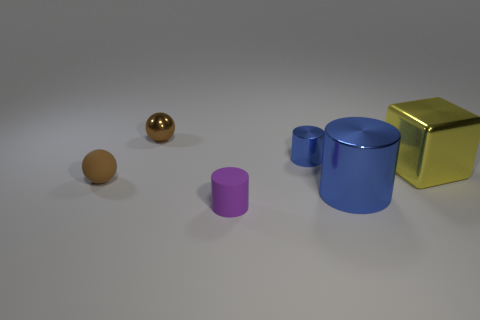Subtract all big cylinders. How many cylinders are left? 2 Subtract all purple balls. How many blue cylinders are left? 2 Subtract 1 cylinders. How many cylinders are left? 2 Add 4 tiny balls. How many objects exist? 10 Subtract all spheres. How many objects are left? 4 Subtract all red cylinders. Subtract all purple spheres. How many cylinders are left? 3 Subtract 0 green cubes. How many objects are left? 6 Subtract all blue metal objects. Subtract all yellow things. How many objects are left? 3 Add 3 tiny metal spheres. How many tiny metal spheres are left? 4 Add 2 large blue shiny cubes. How many large blue shiny cubes exist? 2 